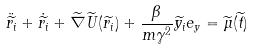<formula> <loc_0><loc_0><loc_500><loc_500>\ddot { \widetilde { r _ { i } } } + \dot { \widetilde { r _ { i } } } + \widetilde { \nabla } \widetilde { U } ( \widetilde { r _ { i } } ) + \frac { \beta } { m \gamma ^ { 2 } } \widetilde { y _ { i } } e _ { y } = \widetilde { \mu } ( \widetilde { t } )</formula> 